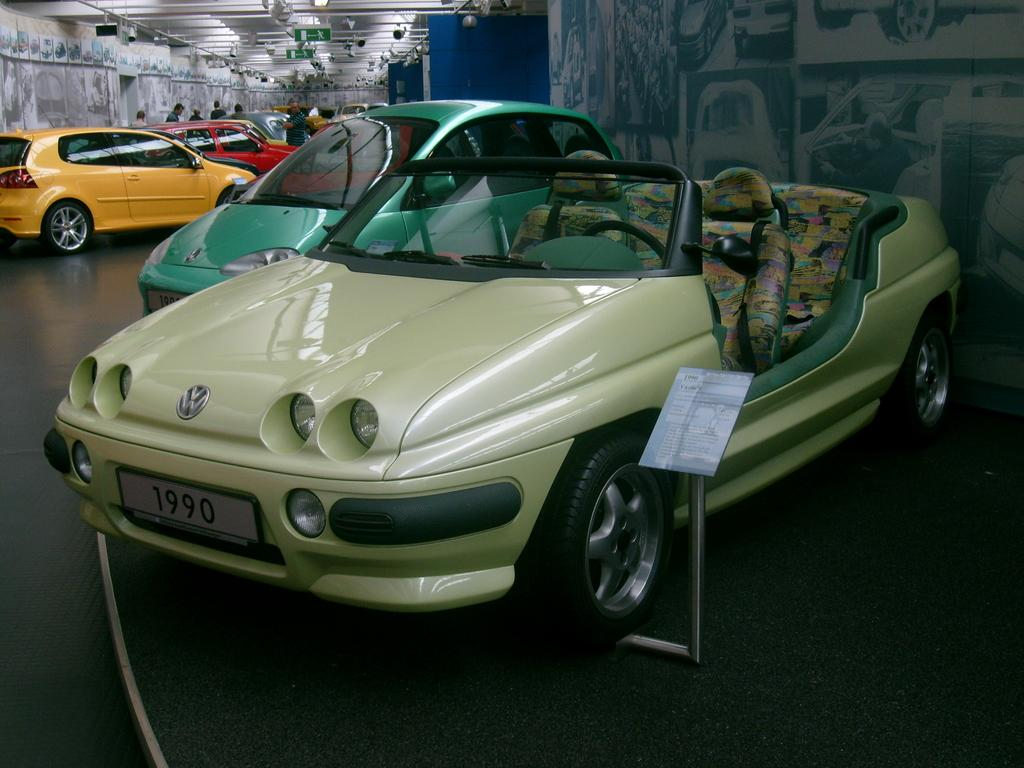What is the main subject of the image? The main subject of the image is many cars. Can you describe the people in the image? Yes, there are people in the background of the image, specifically around the cars. What type of hearing device is the representative wearing in the image? There is no representative or hearing device present in the image; it features many cars and people around them. 